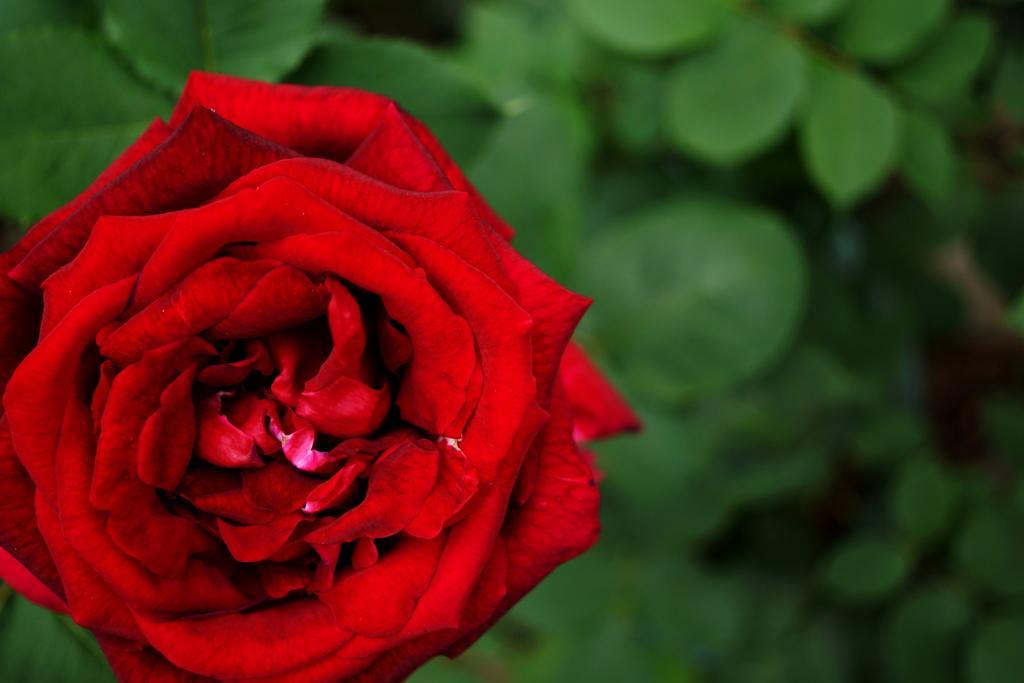Could you give a brief overview of what you see in this image? In this image I can see a red colour rose in the front. In the background I can see number of green colour leaves. I can also see this image is little bit blurry in the background. 